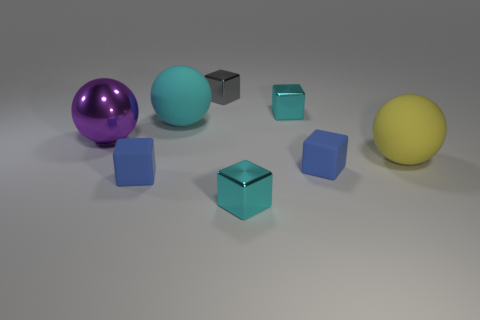How big is the blue thing to the right of the gray object?
Your answer should be very brief. Small. Is the number of things greater than the number of gray metallic objects?
Give a very brief answer. Yes. What material is the tiny gray cube?
Give a very brief answer. Metal. How many cyan shiny objects are there?
Offer a very short reply. 2. There is a purple thing that is the same shape as the yellow rubber object; what is it made of?
Give a very brief answer. Metal. Do the big thing that is in front of the large purple shiny ball and the purple sphere have the same material?
Your response must be concise. No. Are there more cyan shiny cubes in front of the big purple metallic sphere than rubber balls that are on the left side of the big cyan sphere?
Offer a very short reply. Yes. What size is the gray thing?
Provide a short and direct response. Small. What shape is the big yellow object that is made of the same material as the big cyan object?
Offer a very short reply. Sphere. Does the large thing that is in front of the big purple metal thing have the same shape as the big cyan matte object?
Your response must be concise. Yes. 